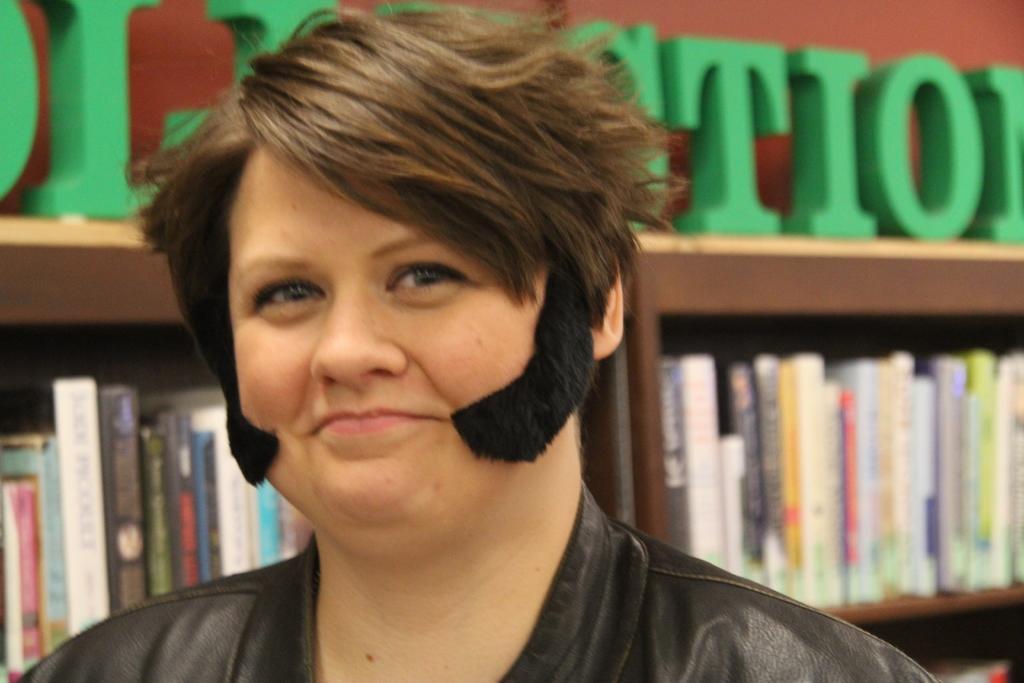Please provide a concise description of this image. In this image, we can see a person. We can also see some shelves with objects like books. We can also see some text in the background. 